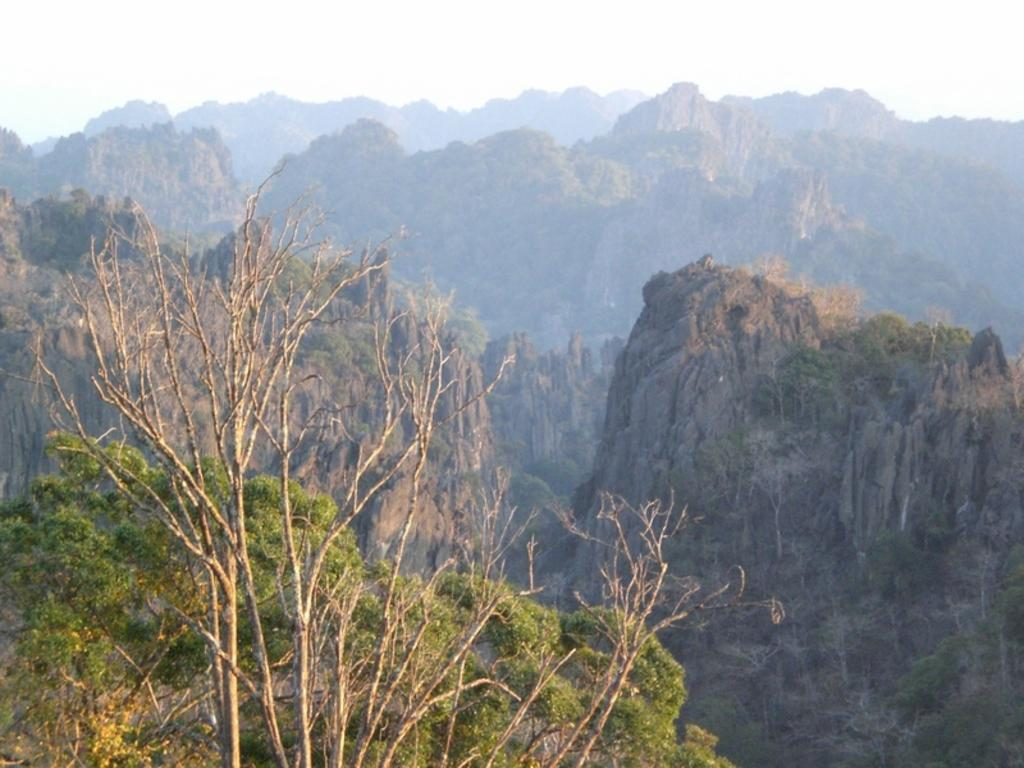What is the main feature in the center of the image? There are mountains in the center of the image. What type of vegetation can be seen at the bottom of the image? There are trees at the bottom of the image. How many cakes are being judged by the judge in the image? There are no cakes or judges present in the image; it features mountains and trees. What is the increase in the number of trees from the left side to the right side of the image? The image does not show a comparison of trees on the left and right sides, so it is not possible to determine an increase. 